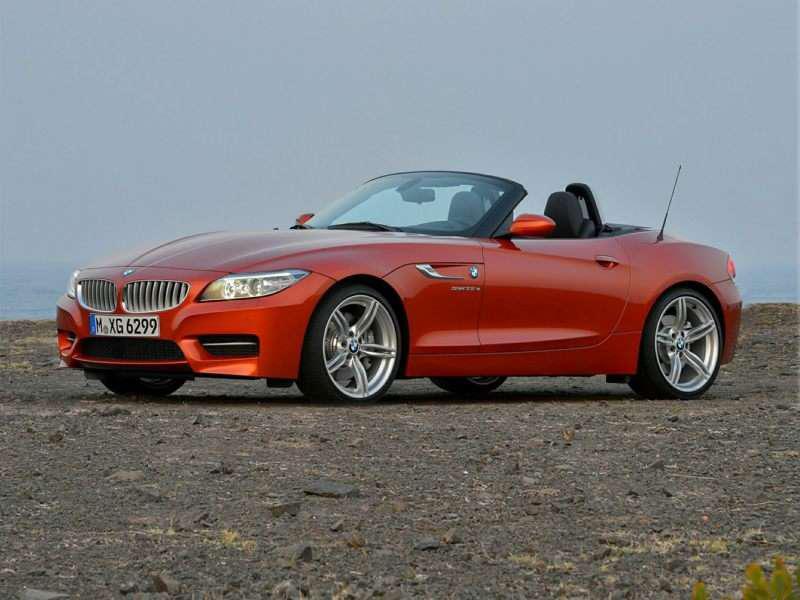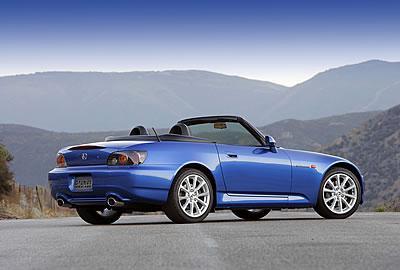The first image is the image on the left, the second image is the image on the right. For the images displayed, is the sentence "There Is a single apple red car with the top down and thin tires facing left on the road." factually correct? Answer yes or no. Yes. The first image is the image on the left, the second image is the image on the right. Examine the images to the left and right. Is the description "There is a blue car facing right in the right image." accurate? Answer yes or no. Yes. 